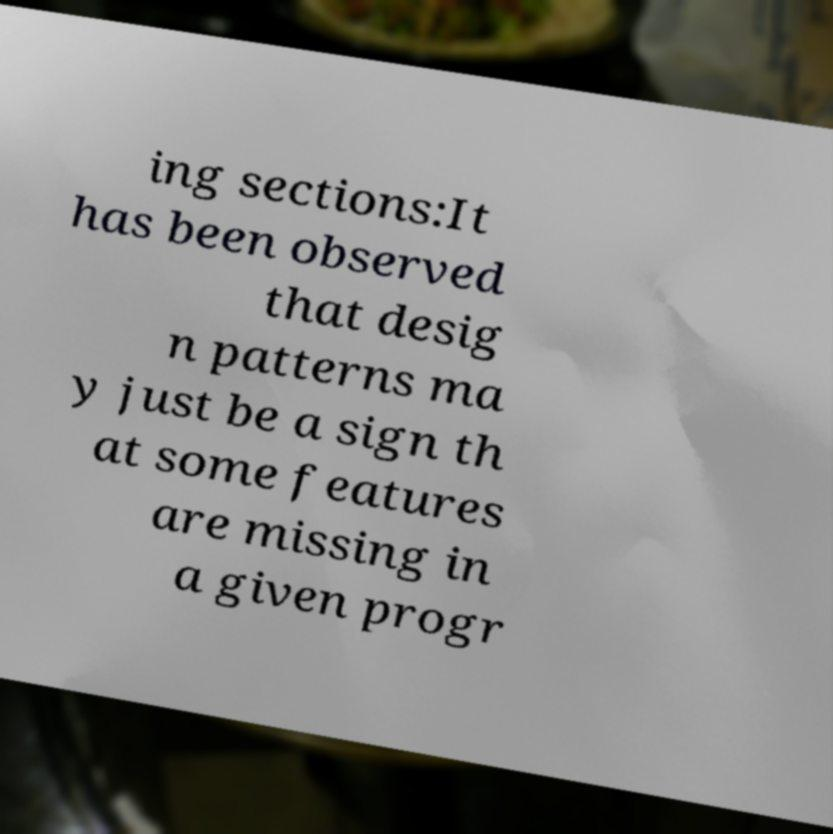Can you accurately transcribe the text from the provided image for me? ing sections:It has been observed that desig n patterns ma y just be a sign th at some features are missing in a given progr 